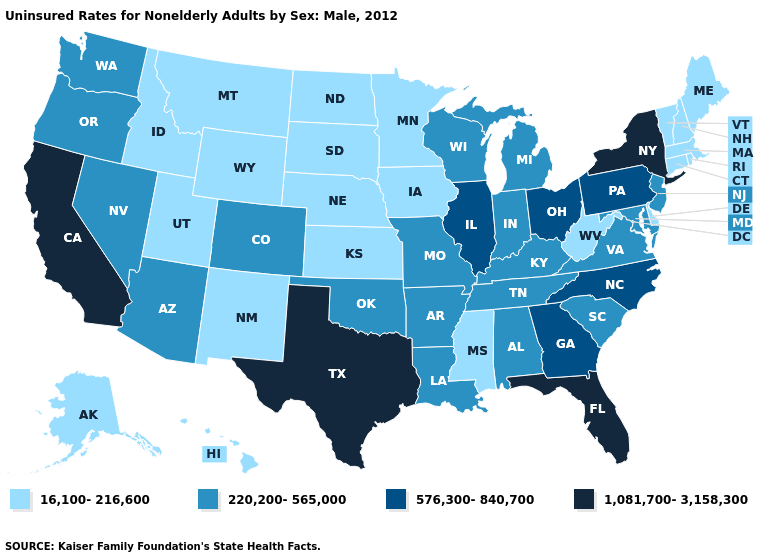Name the states that have a value in the range 1,081,700-3,158,300?
Answer briefly. California, Florida, New York, Texas. How many symbols are there in the legend?
Short answer required. 4. What is the value of Alabama?
Answer briefly. 220,200-565,000. Name the states that have a value in the range 16,100-216,600?
Write a very short answer. Alaska, Connecticut, Delaware, Hawaii, Idaho, Iowa, Kansas, Maine, Massachusetts, Minnesota, Mississippi, Montana, Nebraska, New Hampshire, New Mexico, North Dakota, Rhode Island, South Dakota, Utah, Vermont, West Virginia, Wyoming. Does Utah have the lowest value in the USA?
Short answer required. Yes. What is the highest value in the USA?
Be succinct. 1,081,700-3,158,300. Does Idaho have a higher value than Georgia?
Quick response, please. No. Name the states that have a value in the range 16,100-216,600?
Write a very short answer. Alaska, Connecticut, Delaware, Hawaii, Idaho, Iowa, Kansas, Maine, Massachusetts, Minnesota, Mississippi, Montana, Nebraska, New Hampshire, New Mexico, North Dakota, Rhode Island, South Dakota, Utah, Vermont, West Virginia, Wyoming. What is the highest value in the USA?
Write a very short answer. 1,081,700-3,158,300. Among the states that border Delaware , does Maryland have the lowest value?
Quick response, please. Yes. Does West Virginia have a lower value than Nebraska?
Concise answer only. No. Does the first symbol in the legend represent the smallest category?
Answer briefly. Yes. Name the states that have a value in the range 576,300-840,700?
Answer briefly. Georgia, Illinois, North Carolina, Ohio, Pennsylvania. Which states hav the highest value in the MidWest?
Concise answer only. Illinois, Ohio. What is the lowest value in the West?
Short answer required. 16,100-216,600. 